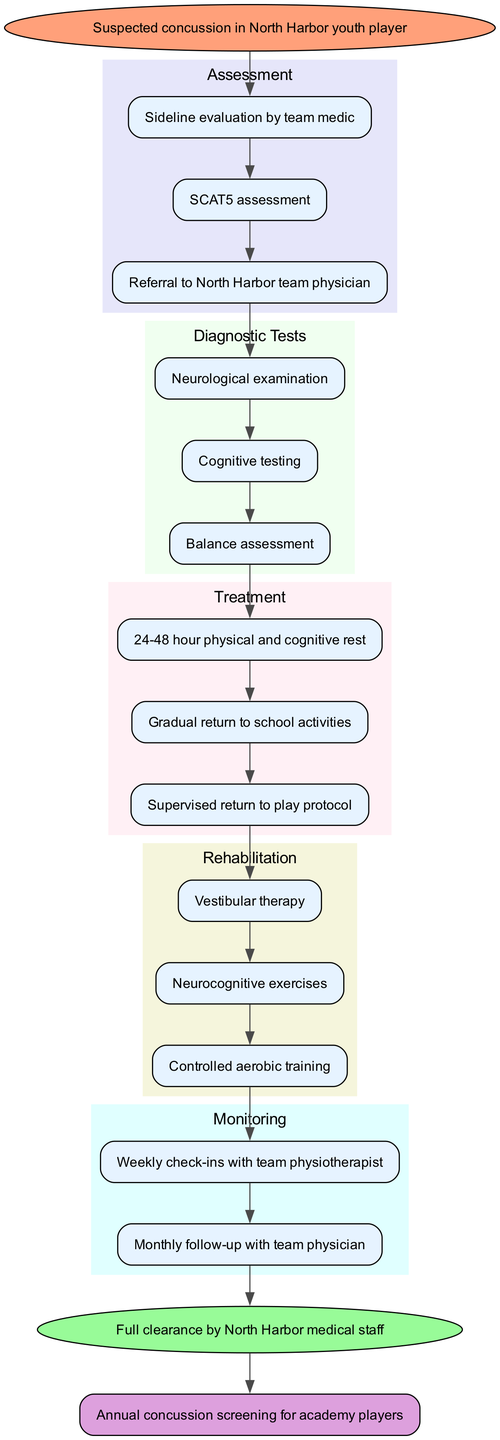What is the first step in the assessment process? The first step listed in the assessment steps is "Sideline evaluation by team medic," which comes directly after the start node.
Answer: Sideline evaluation by team medic How many diagnostic tests are included? There are three diagnostic tests listed in the diagram, which are "Neurological examination," "Cognitive testing," and "Balance assessment." This can be counted as we review the diagnostic testing section.
Answer: 3 What follows after the treatment path? After the treatment path, the next section in the flow is the rehabilitation steps, as indicated by the edge connections within the diagram.
Answer: Rehabilitation steps What is the final step in the pathway? The final step listed is "Annual concussion screening for academy players," which is under the long-term follow-up section after the return to play.
Answer: Annual concussion screening for academy players Which monitoring process involves weekly check-ins? The monitoring process that involves weekly check-ins is "Weekly check-ins with team physiotherapist," mentioned at the start of the monitoring section.
Answer: Weekly check-ins with team physiotherapist What is required for return to play? The requirement stated for return to play is "Full clearance by North Harbor medical staff," which is vital for the player before resuming activities.
Answer: Full clearance by North Harbor medical staff What is the second rehabilitation step? The second rehabilitation step listed is "Neurocognitive exercises," which can be located as the second item in the rehabilitation steps.
Answer: Neurocognitive exercises How is the progression from assessment to diagnostic tests structured? The progression is structured through an edge from the last assessment step, "Referral to North Harbor team physician," leading into the first diagnostic test, "Neurological examination," indicating a flow from assessment to diagnosis.
Answer: Through an edge connection 